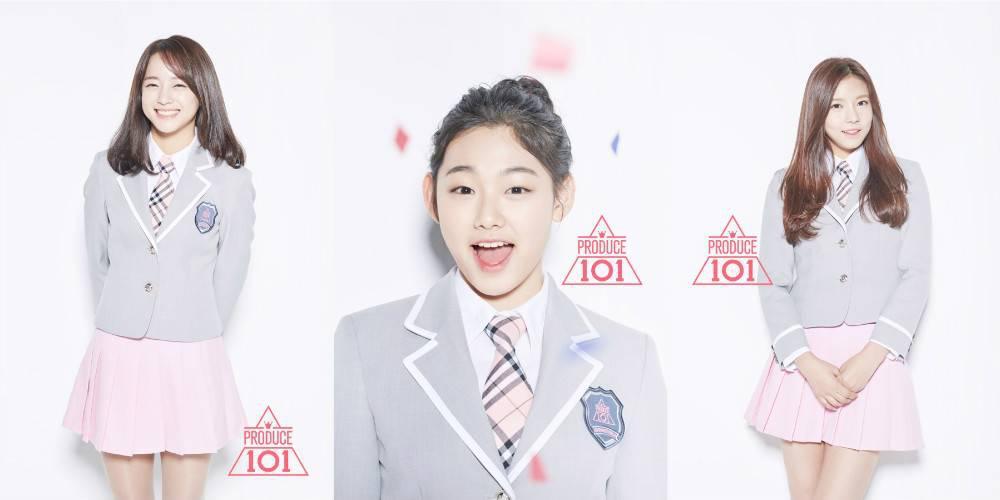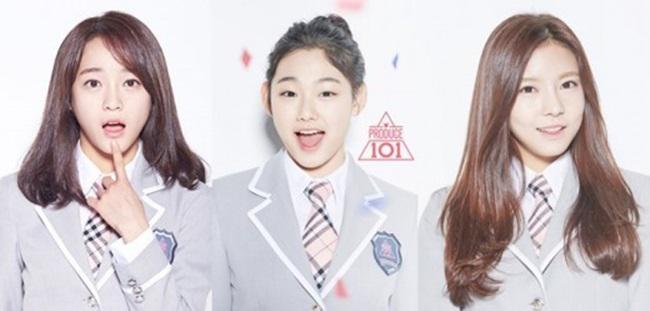The first image is the image on the left, the second image is the image on the right. Examine the images to the left and right. Is the description "There are more than four women in total." accurate? Answer yes or no. Yes. 